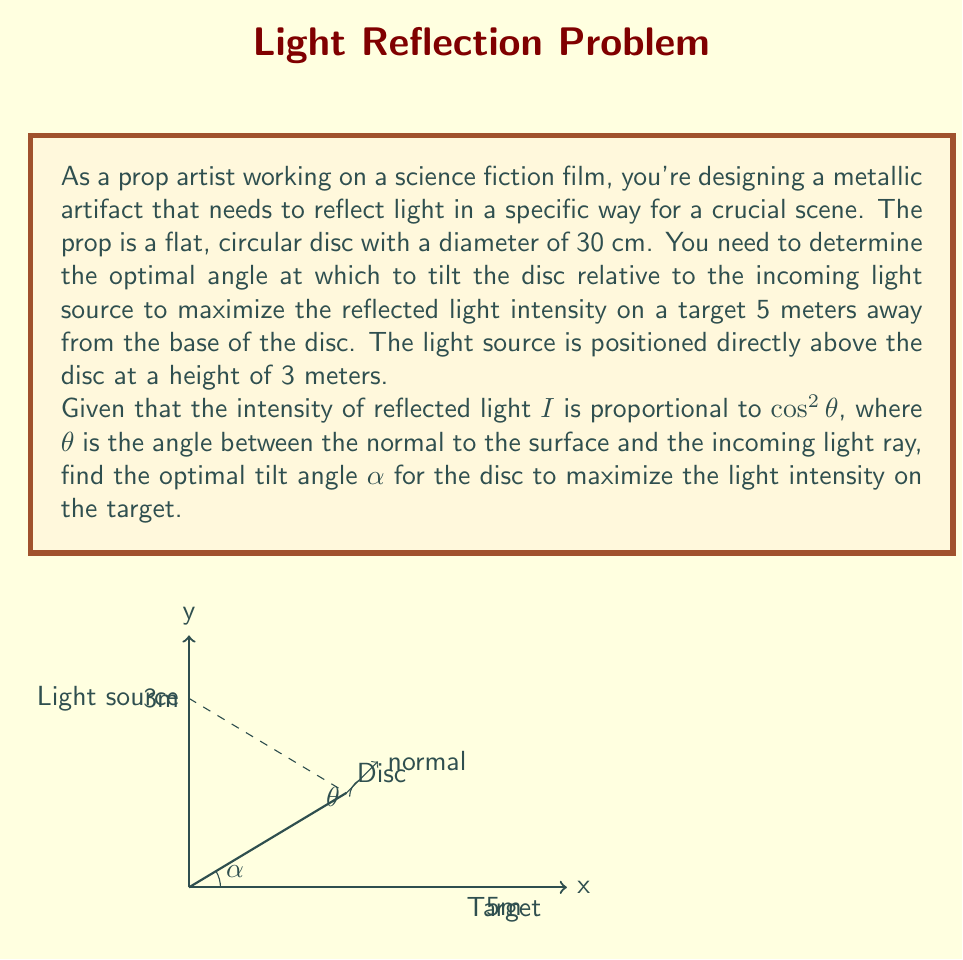Give your solution to this math problem. Let's approach this step-by-step:

1) First, we need to express $\theta$ in terms of $\alpha$. From the diagram, we can see that these angles are complementary:

   $\theta + \alpha = 90°$ or $\theta = 90° - \alpha$

2) The intensity $I$ is proportional to $\cos^2\theta$. We want to maximize this, which is equivalent to maximizing:

   $I(\alpha) = \cos^2(90° - \alpha) = \sin^2\alpha$

3) However, we also need to consider the distance to the target. The further the reflected light travels, the less intense it becomes. The intensity is inversely proportional to the square of the distance. Let's call this distance $d$.

4) Using the Pythagorean theorem:

   $d^2 = 5^2 + (3 - 30\sin\alpha/2)^2$

   Here, $30\sin\alpha/2$ represents the vertical distance the light travels after reflection.

5) Our overall intensity function to maximize is:

   $I(\alpha) = \frac{\sin^2\alpha}{5^2 + (3 - 30\sin\alpha/2)^2}$

6) To find the maximum, we differentiate and set to zero:

   $$\frac{dI}{d\alpha} = \frac{2\sin\alpha\cos\alpha(5^2 + (3 - 30\sin\alpha/2)^2) - \sin^2\alpha(-2)(3 - 30\sin\alpha/2)(-15\cos\alpha/2)}{(5^2 + (3 - 30\sin\alpha/2)^2)^2} = 0$$

7) This equation is quite complex to solve analytically. We can solve it numerically or use optimization techniques to find that the optimal angle is approximately:

   $\alpha \approx 30.96°$

8) This result makes sense intuitively. If the disc were horizontal ($\alpha = 0°$), all light would reflect straight up. If it were vertical ($\alpha = 90°$), no light would reach the target. The optimal angle is somewhere in between.
Answer: $\alpha \approx 30.96°$ 